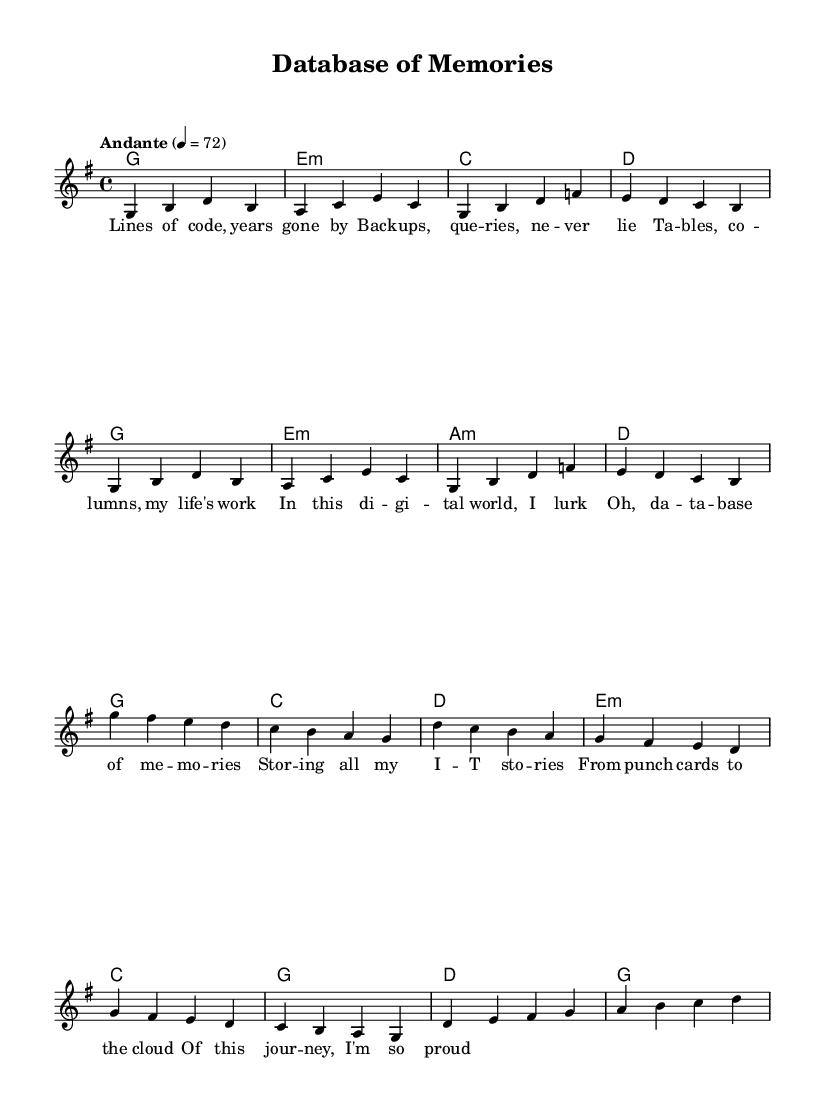What is the key signature of this music? The key signature indicates the key of G major, which has one sharp (F#). This can be identified by looking for the sharp symbol on the staff lines corresponding to F.
Answer: G major What is the time signature of this music? The time signature shown is 4/4, located at the beginning of the score. This means there are four beats in each measure, with each quarter note receiving one beat.
Answer: 4/4 What is the tempo marking for this piece? The tempo marking is "Andante," which suggests a moderate pace. This is indicated clearly near the beginning of the score and is associated with a specific metronomic marking of 72 beats per minute.
Answer: Andante How many measures are in the verse section? By counting the measures in the verse as indicated in the melody section of the score, we see there are a total of 8 measures in the verse.
Answer: 8 What is the first chord of the chorus? The first chord of the chorus can be identified by looking at the harmonies section. It starts with the chord G major, which corresponds to the first chord played during the chorus.
Answer: G How many lines of lyrics are there in the verse? The lyrics of the verse consist of four lines, which are counted directly from the lyrics section right beneath the melody. Each line corresponds to a specific measure in the melody.
Answer: 4 lines Which musical section features lyrics about "data" and "memories"? The lyrics reflecting on "data" and "memories" appear in the chorus section, where it specifically mentions "database of memories," indicating that this is where these themes are explored.
Answer: Chorus 